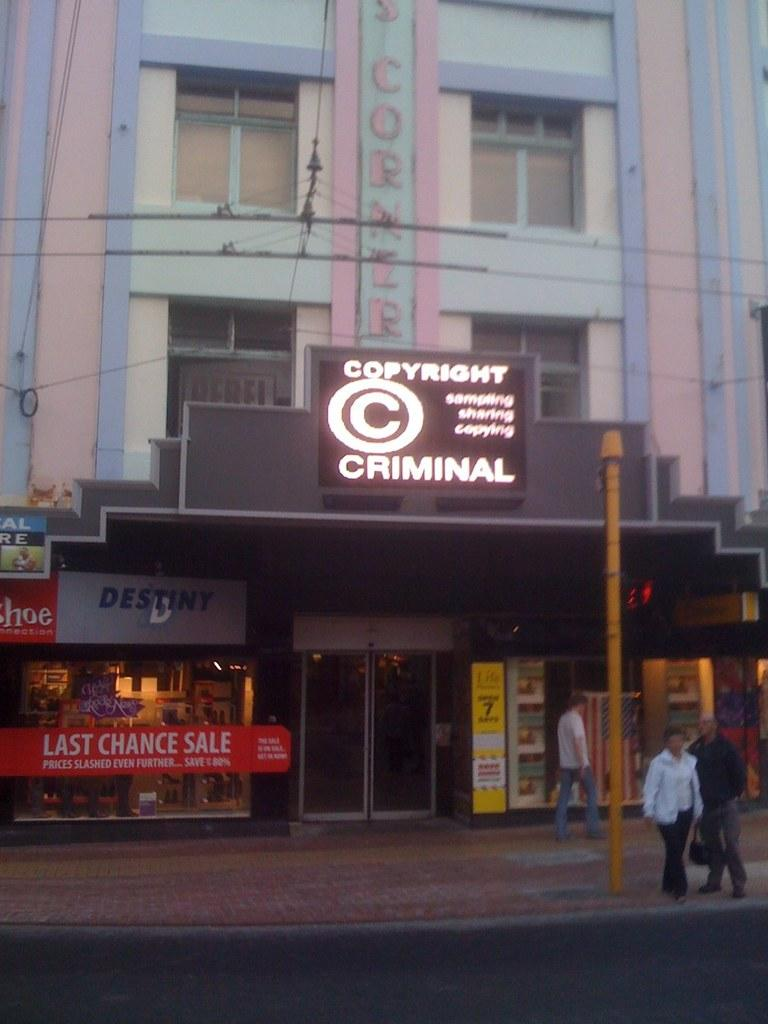How many people are in the image? There are three persons in the image. What can be seen in the image besides the people? There is a pole in the image. What is visible in the background of the image? There are stores and a building visible in the background of the image. What is attached to the building in the background of the image? There are boards attached to the building in the background of the image. What type of guitar can be seen in the sand in the image? There is no guitar or sand present in the image. What emotion do the people in the image feel about their past decisions? The image does not provide any information about the emotions or feelings of the people, so it cannot be determined from the image. 